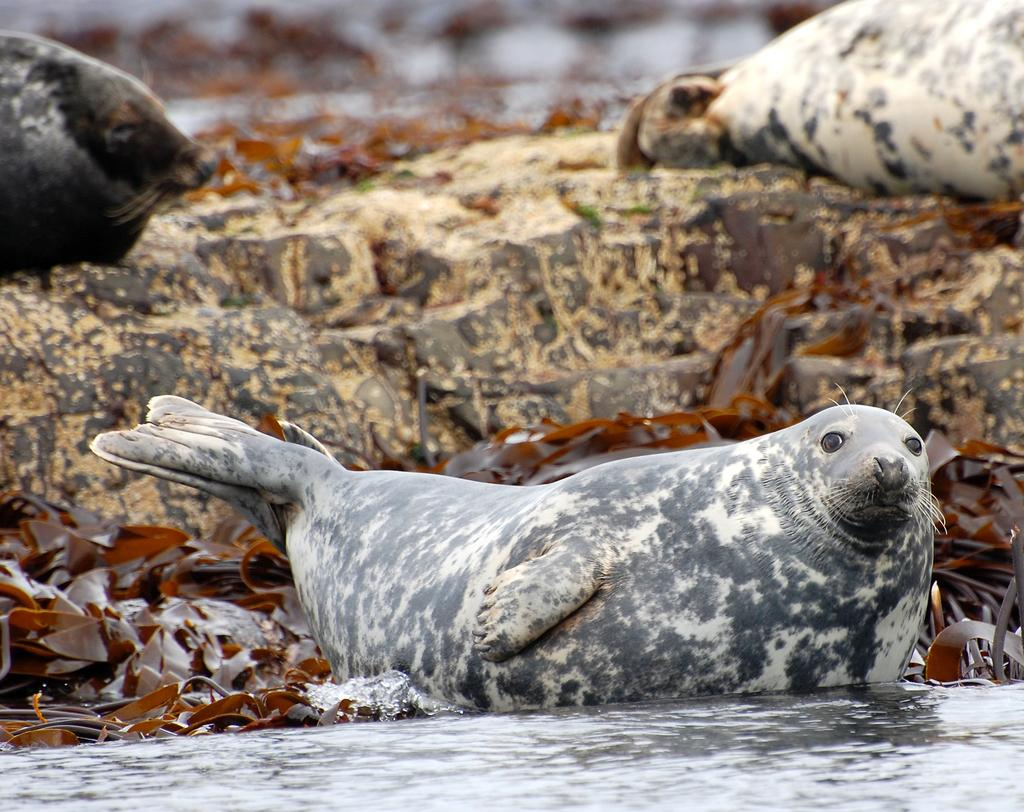What type of animals are in the image? There are seals in the image. What type of vegetation is present in the image? There are leaves in the image. What type of natural formation is in the image? There is a rock in the image. What type of environment is depicted in the image? There is water visible in the image. How would you describe the background of the image? The background of the image is blurry. How many chairs are visible in the image? There are no chairs present in the image. Is there a fire burning in the image? There is no fire present in the image. 